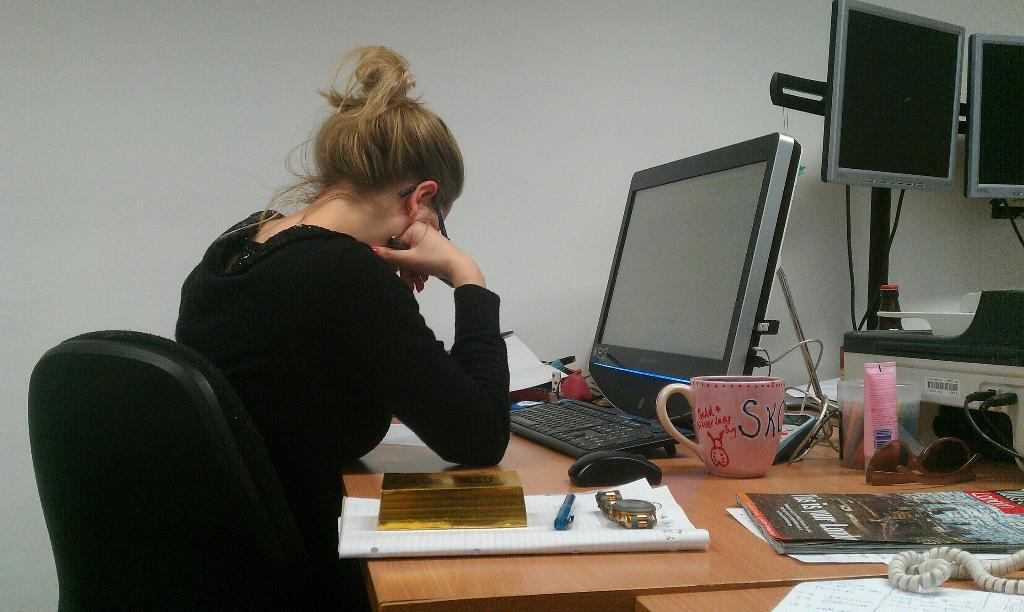Where is the setting of the image? The image is inside a room. What is the woman in the image doing? The woman is sitting on a chair. What electronic devices are present in the image? There is a computer, keyboard, mouse, and telephone in the image. What other objects can be seen in the image? There is a cup, book, watch, pen, goggles, and wires in the image. What type of yard can be seen through the window in the image? There is no window or yard visible in the image. 